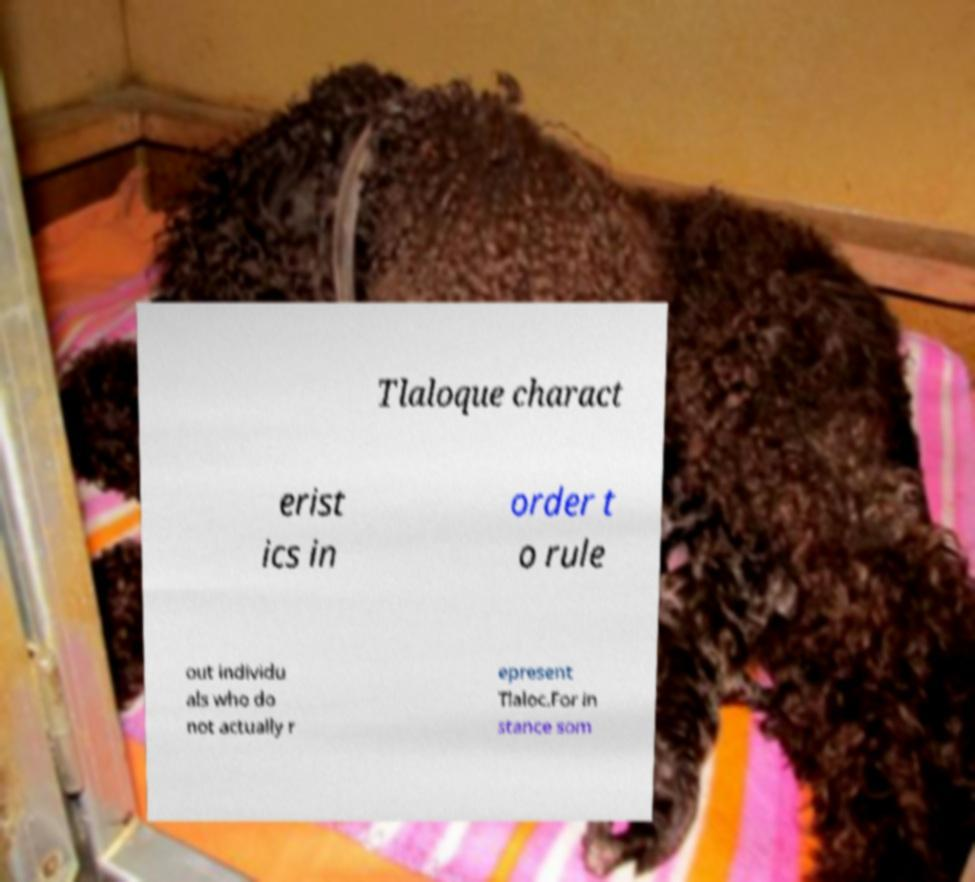For documentation purposes, I need the text within this image transcribed. Could you provide that? Tlaloque charact erist ics in order t o rule out individu als who do not actually r epresent Tlaloc.For in stance som 